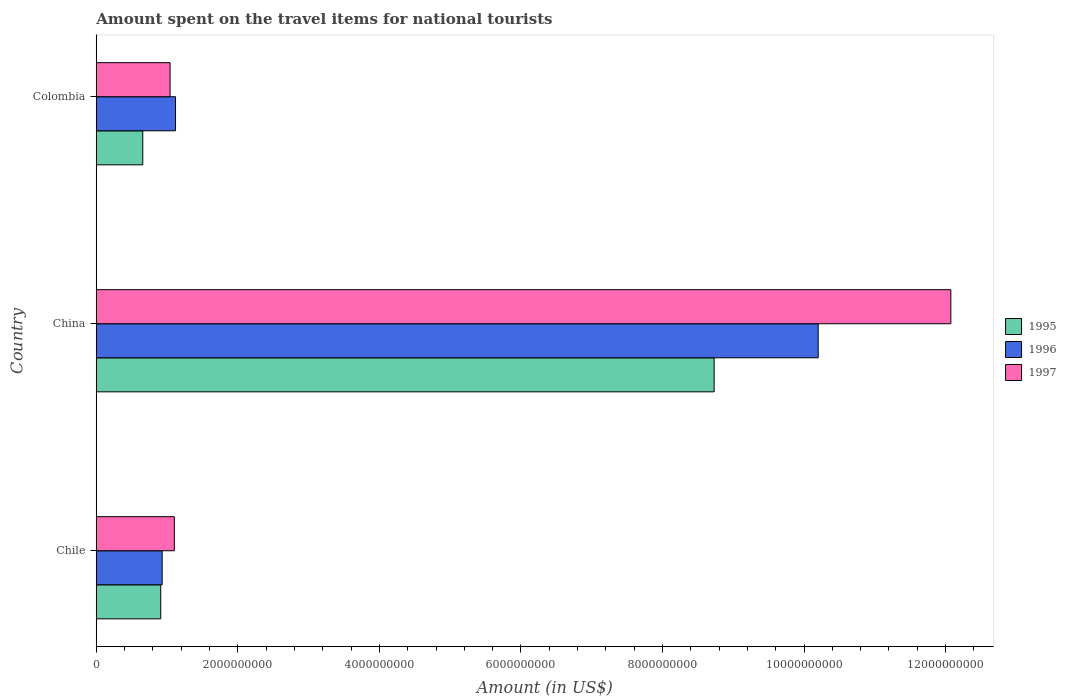How many different coloured bars are there?
Keep it short and to the point. 3. How many groups of bars are there?
Keep it short and to the point. 3. Are the number of bars per tick equal to the number of legend labels?
Your answer should be very brief. Yes. Are the number of bars on each tick of the Y-axis equal?
Your answer should be compact. Yes. How many bars are there on the 3rd tick from the bottom?
Ensure brevity in your answer.  3. What is the label of the 1st group of bars from the top?
Make the answer very short. Colombia. What is the amount spent on the travel items for national tourists in 1997 in Colombia?
Keep it short and to the point. 1.04e+09. Across all countries, what is the maximum amount spent on the travel items for national tourists in 1996?
Your answer should be compact. 1.02e+1. Across all countries, what is the minimum amount spent on the travel items for national tourists in 1997?
Offer a very short reply. 1.04e+09. In which country was the amount spent on the travel items for national tourists in 1996 maximum?
Make the answer very short. China. In which country was the amount spent on the travel items for national tourists in 1995 minimum?
Provide a succinct answer. Colombia. What is the total amount spent on the travel items for national tourists in 1997 in the graph?
Offer a very short reply. 1.42e+1. What is the difference between the amount spent on the travel items for national tourists in 1996 in Chile and that in China?
Give a very brief answer. -9.27e+09. What is the difference between the amount spent on the travel items for national tourists in 1995 in China and the amount spent on the travel items for national tourists in 1997 in Chile?
Keep it short and to the point. 7.63e+09. What is the average amount spent on the travel items for national tourists in 1995 per country?
Offer a terse response. 3.43e+09. What is the difference between the amount spent on the travel items for national tourists in 1997 and amount spent on the travel items for national tourists in 1996 in China?
Make the answer very short. 1.87e+09. In how many countries, is the amount spent on the travel items for national tourists in 1996 greater than 3200000000 US$?
Keep it short and to the point. 1. What is the ratio of the amount spent on the travel items for national tourists in 1997 in China to that in Colombia?
Provide a short and direct response. 11.58. Is the amount spent on the travel items for national tourists in 1995 in Chile less than that in Colombia?
Give a very brief answer. No. Is the difference between the amount spent on the travel items for national tourists in 1997 in China and Colombia greater than the difference between the amount spent on the travel items for national tourists in 1996 in China and Colombia?
Offer a terse response. Yes. What is the difference between the highest and the second highest amount spent on the travel items for national tourists in 1995?
Your answer should be compact. 7.82e+09. What is the difference between the highest and the lowest amount spent on the travel items for national tourists in 1995?
Your answer should be very brief. 8.07e+09. In how many countries, is the amount spent on the travel items for national tourists in 1996 greater than the average amount spent on the travel items for national tourists in 1996 taken over all countries?
Keep it short and to the point. 1. What does the 1st bar from the bottom in Colombia represents?
Keep it short and to the point. 1995. How many bars are there?
Provide a short and direct response. 9. Are all the bars in the graph horizontal?
Offer a very short reply. Yes. Are the values on the major ticks of X-axis written in scientific E-notation?
Ensure brevity in your answer.  No. Does the graph contain any zero values?
Your answer should be compact. No. Where does the legend appear in the graph?
Your answer should be very brief. Center right. How many legend labels are there?
Offer a terse response. 3. How are the legend labels stacked?
Your answer should be compact. Vertical. What is the title of the graph?
Provide a succinct answer. Amount spent on the travel items for national tourists. Does "1989" appear as one of the legend labels in the graph?
Provide a short and direct response. No. What is the label or title of the X-axis?
Provide a short and direct response. Amount (in US$). What is the label or title of the Y-axis?
Give a very brief answer. Country. What is the Amount (in US$) in 1995 in Chile?
Your response must be concise. 9.11e+08. What is the Amount (in US$) of 1996 in Chile?
Your answer should be compact. 9.31e+08. What is the Amount (in US$) in 1997 in Chile?
Give a very brief answer. 1.10e+09. What is the Amount (in US$) of 1995 in China?
Give a very brief answer. 8.73e+09. What is the Amount (in US$) in 1996 in China?
Make the answer very short. 1.02e+1. What is the Amount (in US$) of 1997 in China?
Your answer should be very brief. 1.21e+1. What is the Amount (in US$) of 1995 in Colombia?
Give a very brief answer. 6.57e+08. What is the Amount (in US$) of 1996 in Colombia?
Offer a terse response. 1.12e+09. What is the Amount (in US$) in 1997 in Colombia?
Keep it short and to the point. 1.04e+09. Across all countries, what is the maximum Amount (in US$) of 1995?
Ensure brevity in your answer.  8.73e+09. Across all countries, what is the maximum Amount (in US$) in 1996?
Ensure brevity in your answer.  1.02e+1. Across all countries, what is the maximum Amount (in US$) in 1997?
Keep it short and to the point. 1.21e+1. Across all countries, what is the minimum Amount (in US$) of 1995?
Provide a short and direct response. 6.57e+08. Across all countries, what is the minimum Amount (in US$) in 1996?
Offer a terse response. 9.31e+08. Across all countries, what is the minimum Amount (in US$) of 1997?
Your answer should be very brief. 1.04e+09. What is the total Amount (in US$) in 1995 in the graph?
Keep it short and to the point. 1.03e+1. What is the total Amount (in US$) in 1996 in the graph?
Your answer should be compact. 1.23e+1. What is the total Amount (in US$) of 1997 in the graph?
Your response must be concise. 1.42e+1. What is the difference between the Amount (in US$) in 1995 in Chile and that in China?
Provide a succinct answer. -7.82e+09. What is the difference between the Amount (in US$) of 1996 in Chile and that in China?
Make the answer very short. -9.27e+09. What is the difference between the Amount (in US$) of 1997 in Chile and that in China?
Offer a very short reply. -1.10e+1. What is the difference between the Amount (in US$) of 1995 in Chile and that in Colombia?
Your answer should be very brief. 2.54e+08. What is the difference between the Amount (in US$) of 1996 in Chile and that in Colombia?
Offer a very short reply. -1.89e+08. What is the difference between the Amount (in US$) of 1997 in Chile and that in Colombia?
Offer a very short reply. 6.00e+07. What is the difference between the Amount (in US$) of 1995 in China and that in Colombia?
Offer a very short reply. 8.07e+09. What is the difference between the Amount (in US$) in 1996 in China and that in Colombia?
Keep it short and to the point. 9.08e+09. What is the difference between the Amount (in US$) in 1997 in China and that in Colombia?
Give a very brief answer. 1.10e+1. What is the difference between the Amount (in US$) in 1995 in Chile and the Amount (in US$) in 1996 in China?
Keep it short and to the point. -9.29e+09. What is the difference between the Amount (in US$) in 1995 in Chile and the Amount (in US$) in 1997 in China?
Provide a succinct answer. -1.12e+1. What is the difference between the Amount (in US$) of 1996 in Chile and the Amount (in US$) of 1997 in China?
Your answer should be very brief. -1.11e+1. What is the difference between the Amount (in US$) of 1995 in Chile and the Amount (in US$) of 1996 in Colombia?
Offer a terse response. -2.09e+08. What is the difference between the Amount (in US$) in 1995 in Chile and the Amount (in US$) in 1997 in Colombia?
Offer a terse response. -1.32e+08. What is the difference between the Amount (in US$) in 1996 in Chile and the Amount (in US$) in 1997 in Colombia?
Your response must be concise. -1.12e+08. What is the difference between the Amount (in US$) in 1995 in China and the Amount (in US$) in 1996 in Colombia?
Keep it short and to the point. 7.61e+09. What is the difference between the Amount (in US$) of 1995 in China and the Amount (in US$) of 1997 in Colombia?
Your answer should be compact. 7.69e+09. What is the difference between the Amount (in US$) of 1996 in China and the Amount (in US$) of 1997 in Colombia?
Your response must be concise. 9.16e+09. What is the average Amount (in US$) in 1995 per country?
Your answer should be very brief. 3.43e+09. What is the average Amount (in US$) of 1996 per country?
Make the answer very short. 4.08e+09. What is the average Amount (in US$) of 1997 per country?
Ensure brevity in your answer.  4.74e+09. What is the difference between the Amount (in US$) of 1995 and Amount (in US$) of 1996 in Chile?
Make the answer very short. -2.00e+07. What is the difference between the Amount (in US$) of 1995 and Amount (in US$) of 1997 in Chile?
Your answer should be compact. -1.92e+08. What is the difference between the Amount (in US$) of 1996 and Amount (in US$) of 1997 in Chile?
Your response must be concise. -1.72e+08. What is the difference between the Amount (in US$) in 1995 and Amount (in US$) in 1996 in China?
Make the answer very short. -1.47e+09. What is the difference between the Amount (in US$) of 1995 and Amount (in US$) of 1997 in China?
Your answer should be very brief. -3.34e+09. What is the difference between the Amount (in US$) in 1996 and Amount (in US$) in 1997 in China?
Offer a terse response. -1.87e+09. What is the difference between the Amount (in US$) in 1995 and Amount (in US$) in 1996 in Colombia?
Your answer should be very brief. -4.63e+08. What is the difference between the Amount (in US$) of 1995 and Amount (in US$) of 1997 in Colombia?
Offer a terse response. -3.86e+08. What is the difference between the Amount (in US$) of 1996 and Amount (in US$) of 1997 in Colombia?
Your answer should be very brief. 7.70e+07. What is the ratio of the Amount (in US$) in 1995 in Chile to that in China?
Provide a short and direct response. 0.1. What is the ratio of the Amount (in US$) of 1996 in Chile to that in China?
Make the answer very short. 0.09. What is the ratio of the Amount (in US$) of 1997 in Chile to that in China?
Ensure brevity in your answer.  0.09. What is the ratio of the Amount (in US$) of 1995 in Chile to that in Colombia?
Offer a very short reply. 1.39. What is the ratio of the Amount (in US$) of 1996 in Chile to that in Colombia?
Your answer should be compact. 0.83. What is the ratio of the Amount (in US$) of 1997 in Chile to that in Colombia?
Your answer should be compact. 1.06. What is the ratio of the Amount (in US$) in 1995 in China to that in Colombia?
Provide a short and direct response. 13.29. What is the ratio of the Amount (in US$) of 1996 in China to that in Colombia?
Your answer should be very brief. 9.11. What is the ratio of the Amount (in US$) in 1997 in China to that in Colombia?
Make the answer very short. 11.58. What is the difference between the highest and the second highest Amount (in US$) of 1995?
Your response must be concise. 7.82e+09. What is the difference between the highest and the second highest Amount (in US$) of 1996?
Keep it short and to the point. 9.08e+09. What is the difference between the highest and the second highest Amount (in US$) of 1997?
Provide a short and direct response. 1.10e+1. What is the difference between the highest and the lowest Amount (in US$) of 1995?
Offer a very short reply. 8.07e+09. What is the difference between the highest and the lowest Amount (in US$) in 1996?
Make the answer very short. 9.27e+09. What is the difference between the highest and the lowest Amount (in US$) of 1997?
Offer a terse response. 1.10e+1. 